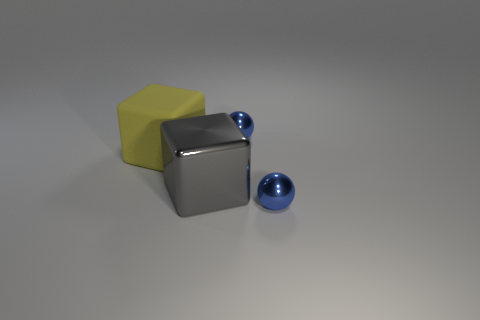Can you describe the lighting and shadows in the scene? The scene is illuminated from above, as indicated by the soft shadows cast downward and to the right of the objects. These shadows are diffuse, suggesting the light source is not overly pinpointed but more gentle and broad, creating a calm atmosphere with soft gradations of light and dark on the surfaces and floor. 